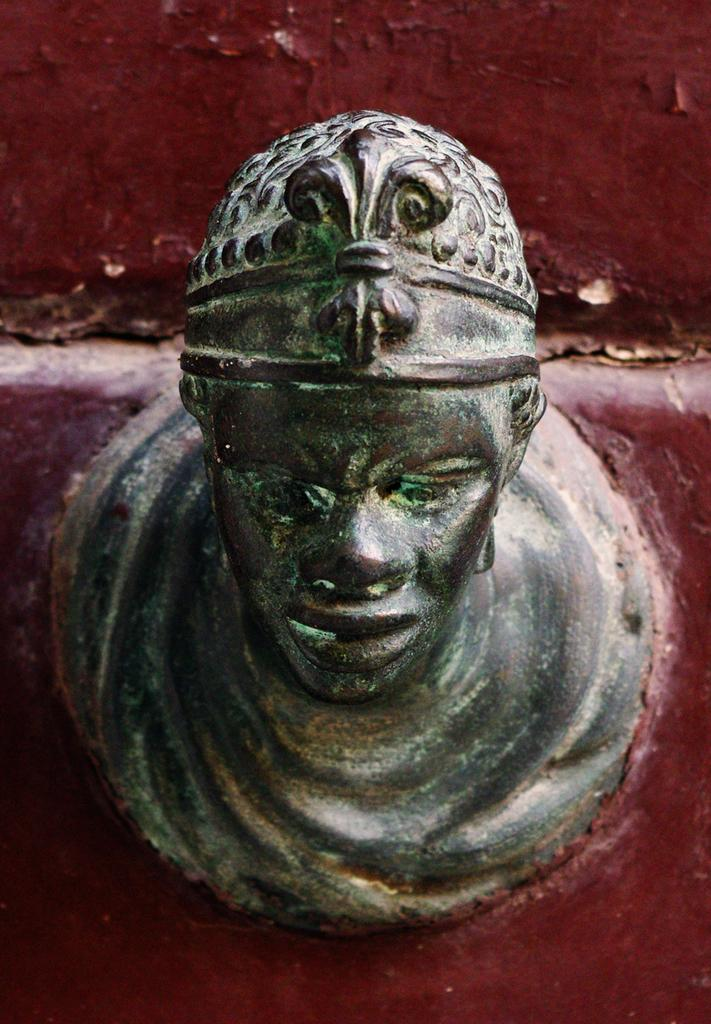What is the main subject in the middle of the picture? There is a sculpture in the middle of the picture. What can be seen in the background of the picture? There is a maroon color wall in the background of the picture. How many bananas are hanging from the glove in the image? There are no bananas or gloves present in the image; it features a sculpture and a maroon color wall in the background. 